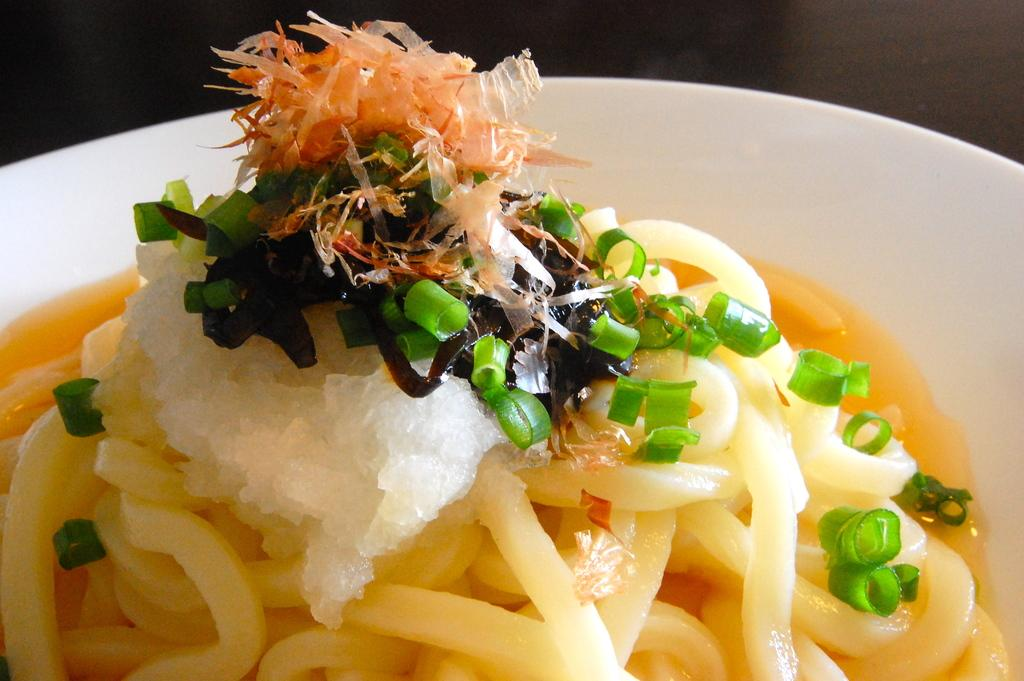What is present on the plate in the image? There is food on a plate in the image. What type of creature is flying in the image? There is no creature present in the image, let alone one that is flying. 